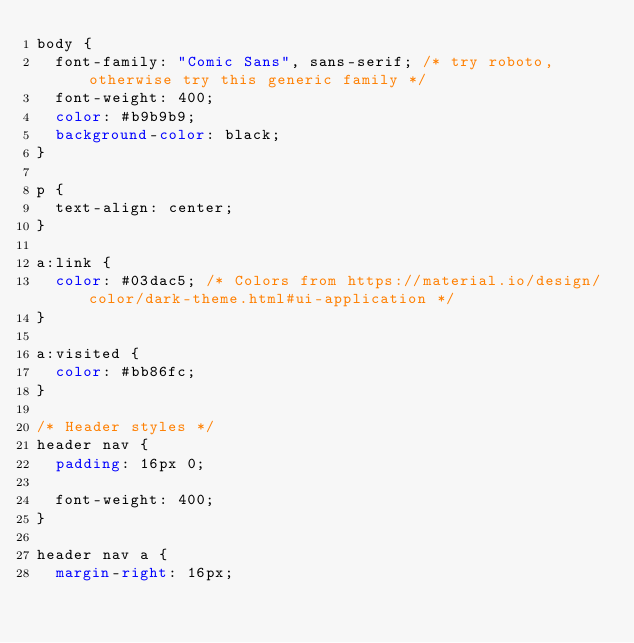Convert code to text. <code><loc_0><loc_0><loc_500><loc_500><_CSS_>body {
  font-family: "Comic Sans", sans-serif; /* try roboto, otherwise try this generic family */
  font-weight: 400;
  color: #b9b9b9;
  background-color: black;
}

p {
  text-align: center;
}

a:link {
  color: #03dac5; /* Colors from https://material.io/design/color/dark-theme.html#ui-application */
}

a:visited {
  color: #bb86fc;
}

/* Header styles */
header nav {
  padding: 16px 0;

  font-weight: 400;
}

header nav a {
  margin-right: 16px;
</code> 